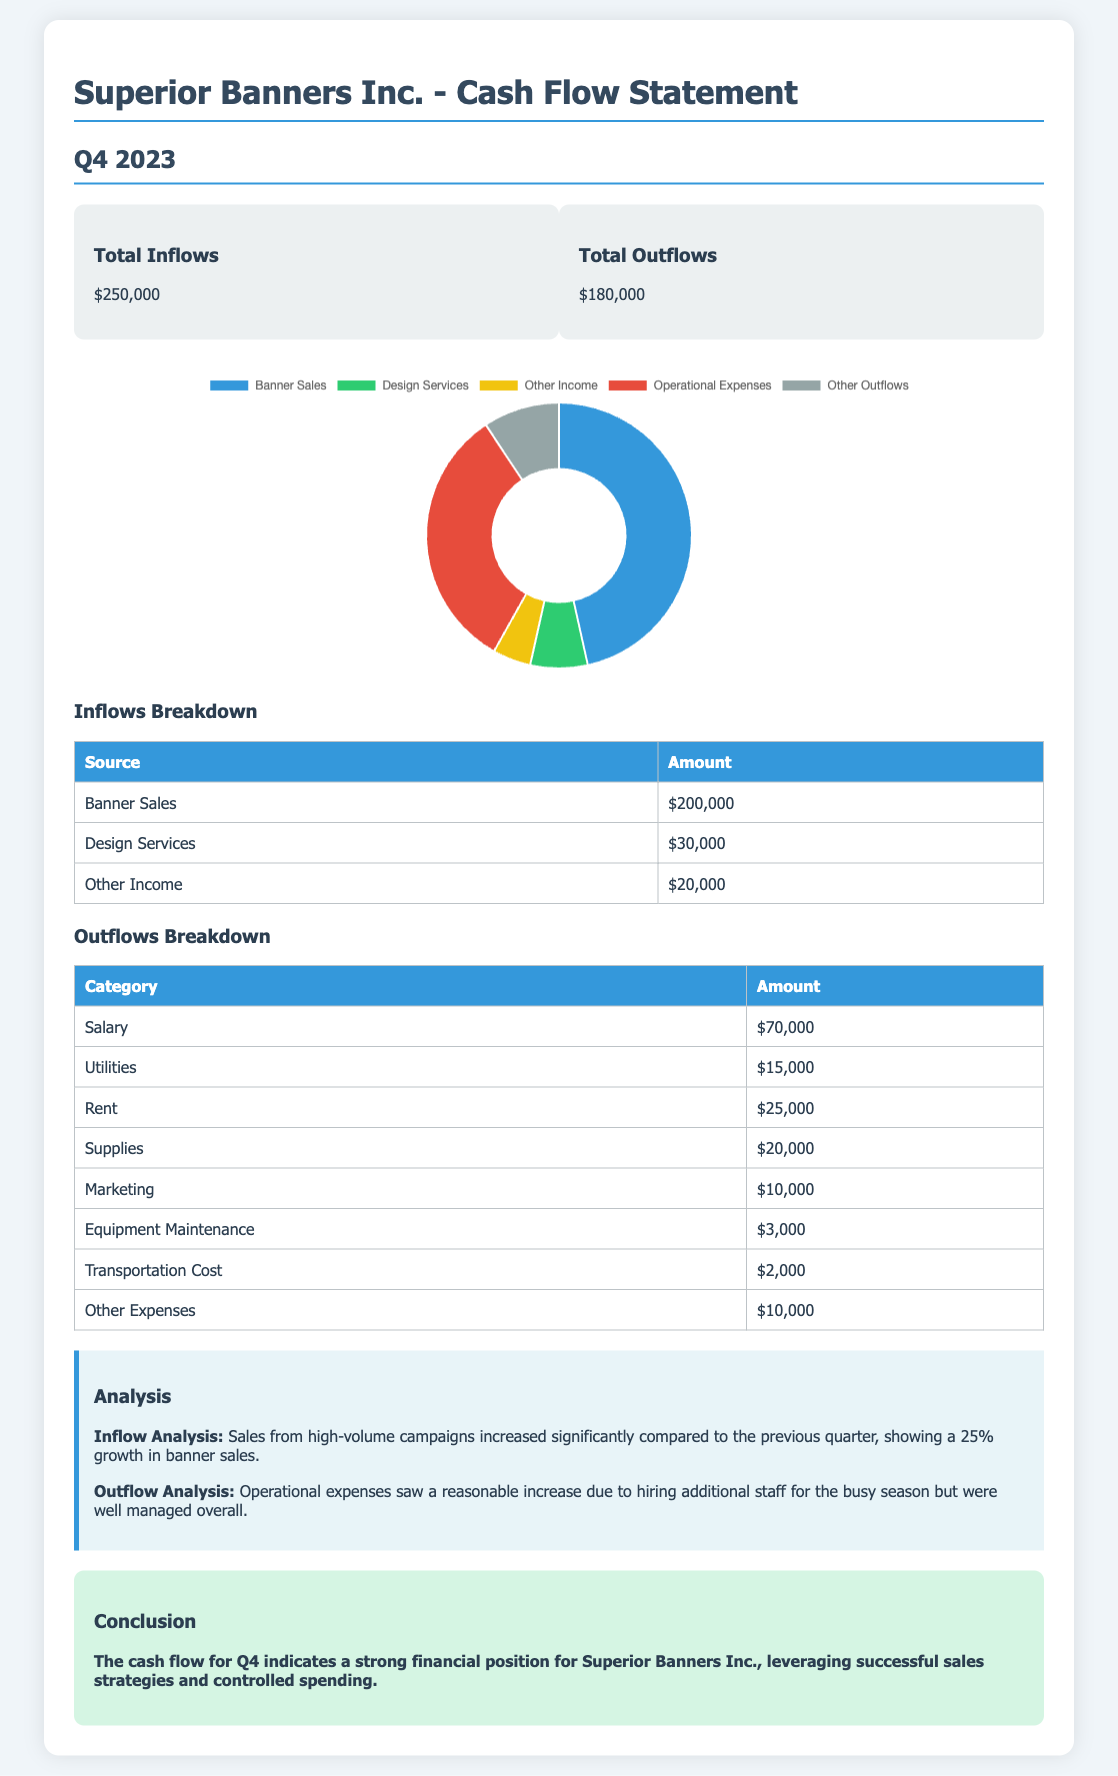What is the total inflow for Q4 2023? The total inflow is specified in the document and is $250,000.
Answer: $250,000 What is the amount earned from banner sales? The document details that banner sales contributed $200,000 to the inflows.
Answer: $200,000 How much was spent on salaries? The salary expenditure is listed in the outflows table as $70,000.
Answer: $70,000 What was the total outflow for Q4 2023? The document states the total outflow is $180,000.
Answer: $180,000 What percentage growth was observed in banner sales compared to the previous quarter? The document mentions a 25% growth in banner sales compared to the previous quarter.
Answer: 25% Which category has the highest expenditure in operational expenses? Among the operational expenses, salary has the highest amount of $70,000 according to the document.
Answer: Salary What is the total amount from design services? The total revenue generated from design services is noted in the inflows table as $30,000.
Answer: $30,000 What is the sum of outflows for rent and utilities? The combined total for rent ($25,000) and utilities ($15,000) is calculated from the outflow details.
Answer: $40,000 What conclusion does the report reach about Superior Banners Inc.? The conclusion drawn states a strong financial position for Superior Banners Inc. in Q4 2023.
Answer: Strong financial position 